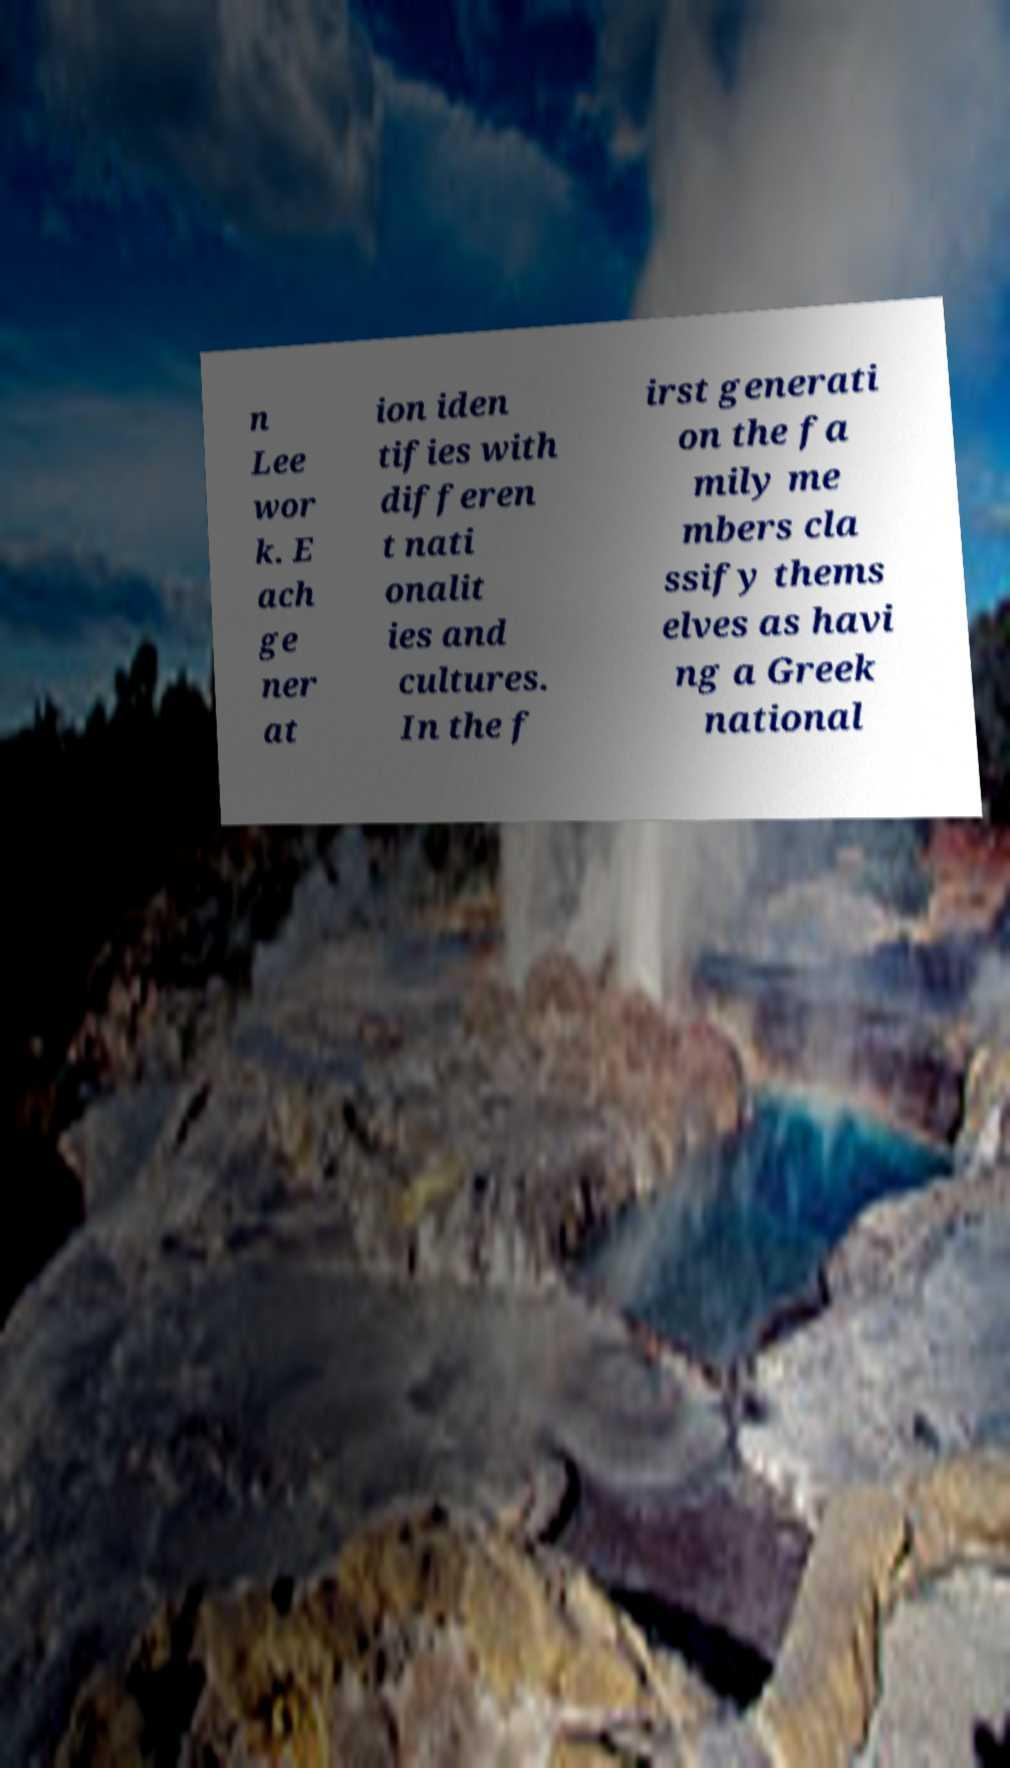Please identify and transcribe the text found in this image. n Lee wor k. E ach ge ner at ion iden tifies with differen t nati onalit ies and cultures. In the f irst generati on the fa mily me mbers cla ssify thems elves as havi ng a Greek national 